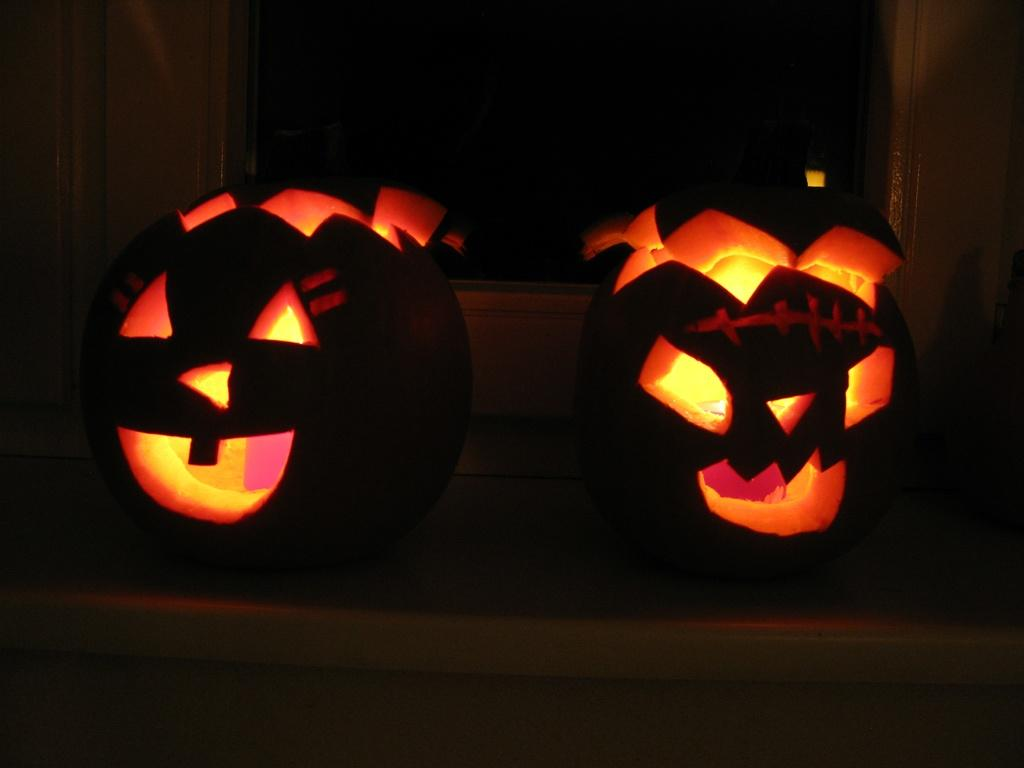What objects are featured in the image? There are two carved pumpkins in the image. What color is the background of the image? The background of the image is black. Can you describe the lighting conditions in the image? The image was likely taken in a dark environment. What type of quiver can be seen in the image? There is no quiver present in the image; it features two carved pumpkins. Can you tell me how many bookshelves or a library setting in the image? The image does not depict a library setting; the background is black, and the main subjects are pumpkins. 